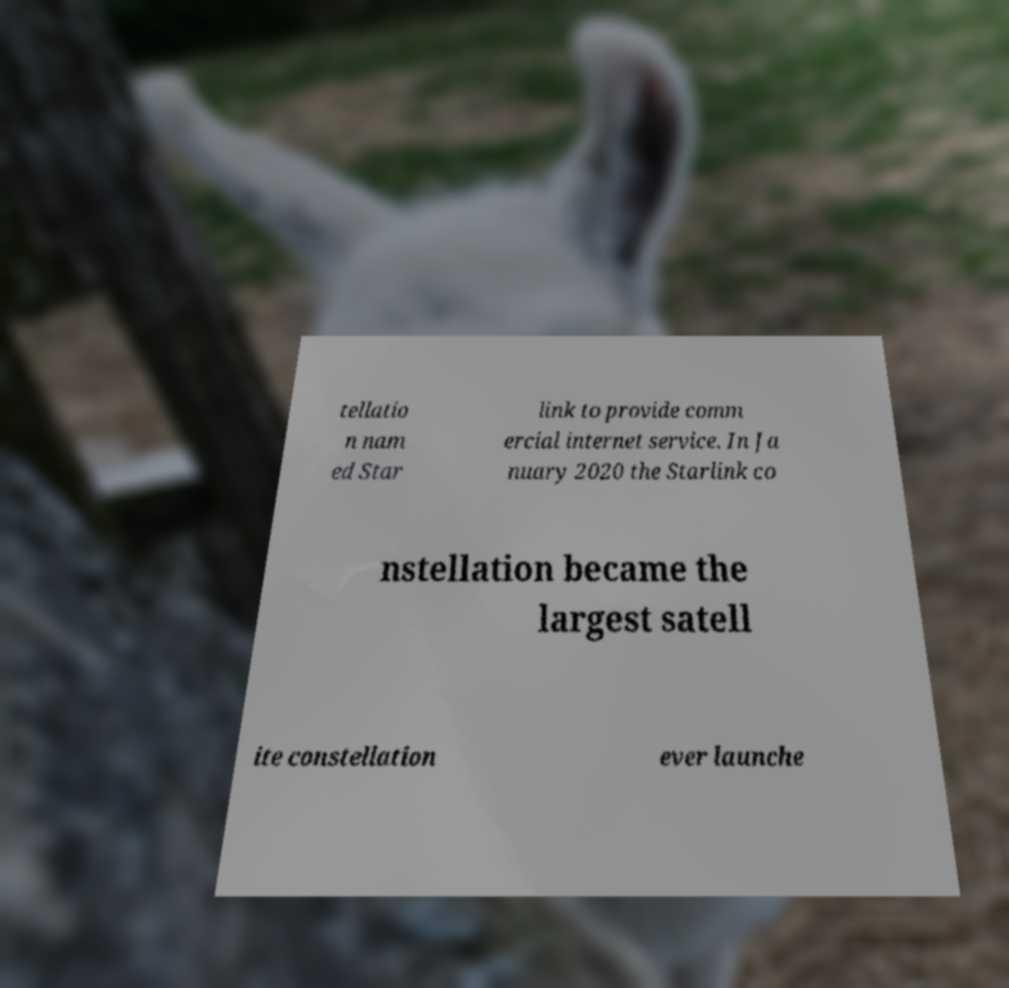I need the written content from this picture converted into text. Can you do that? tellatio n nam ed Star link to provide comm ercial internet service. In Ja nuary 2020 the Starlink co nstellation became the largest satell ite constellation ever launche 